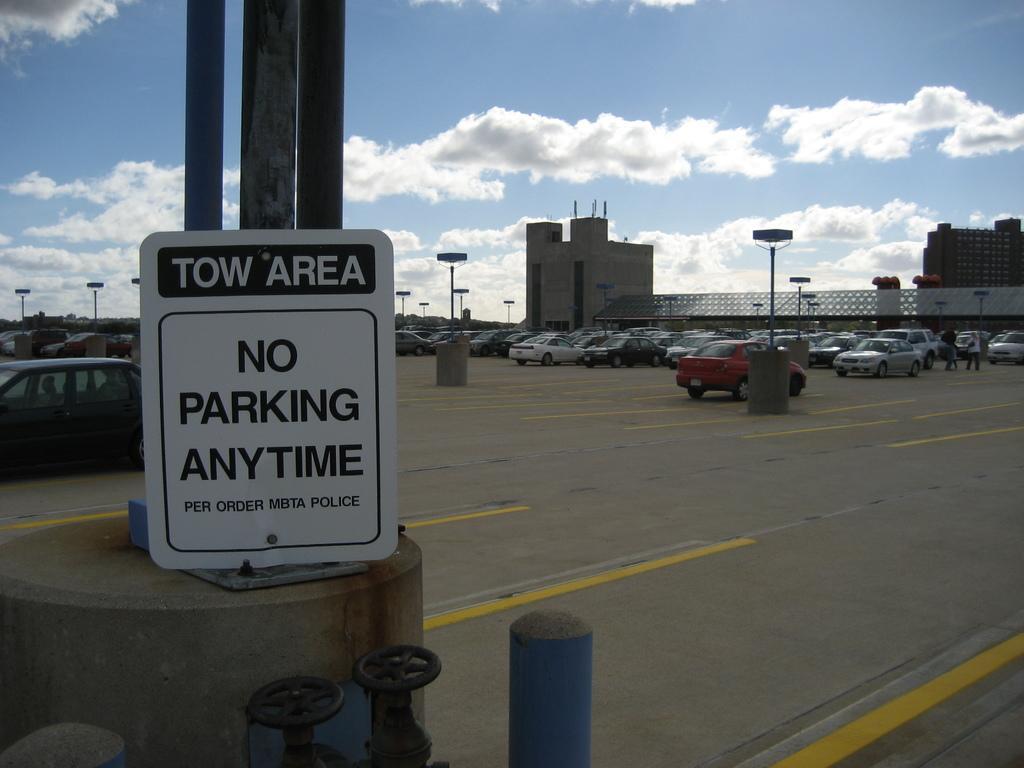Can you describe this image briefly? In this picture there are vehicles on the road. In the foreground there is a board on the pole and there is text on the board. At the back there are buildings and street lights. At the top there is sky and there are clouds. At the bottom there is a road. 